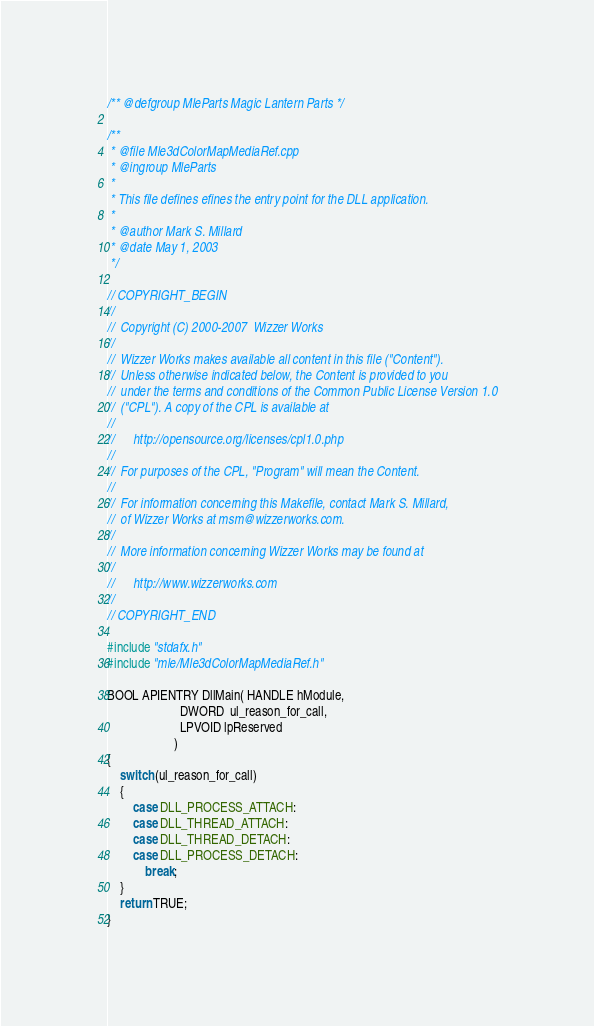Convert code to text. <code><loc_0><loc_0><loc_500><loc_500><_C++_>/** @defgroup MleParts Magic Lantern Parts */

/**
 * @file Mle3dColorMapMediaRef.cpp
 * @ingroup MleParts
 *
 * This file defines efines the entry point for the DLL application.
 *
 * @author Mark S. Millard
 * @date May 1, 2003
 */

// COPYRIGHT_BEGIN
//
//  Copyright (C) 2000-2007  Wizzer Works
//
//  Wizzer Works makes available all content in this file ("Content").
//  Unless otherwise indicated below, the Content is provided to you
//  under the terms and conditions of the Common Public License Version 1.0
//  ("CPL"). A copy of the CPL is available at
//
//      http://opensource.org/licenses/cpl1.0.php
//
//  For purposes of the CPL, "Program" will mean the Content.
//
//  For information concerning this Makefile, contact Mark S. Millard,
//  of Wizzer Works at msm@wizzerworks.com.
//
//  More information concerning Wizzer Works may be found at
//
//      http://www.wizzerworks.com
//
// COPYRIGHT_END

#include "stdafx.h"
#include "mle/Mle3dColorMapMediaRef.h"

BOOL APIENTRY DllMain( HANDLE hModule, 
                       DWORD  ul_reason_for_call, 
                       LPVOID lpReserved
					 )
{
    switch (ul_reason_for_call)
	{
		case DLL_PROCESS_ATTACH:
		case DLL_THREAD_ATTACH:
		case DLL_THREAD_DETACH:
		case DLL_PROCESS_DETACH:
			break;
    }
    return TRUE;
}
</code> 